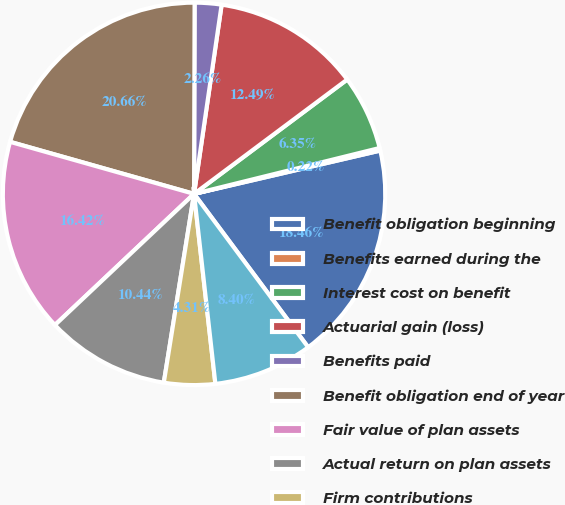<chart> <loc_0><loc_0><loc_500><loc_500><pie_chart><fcel>Benefit obligation beginning<fcel>Benefits earned during the<fcel>Interest cost on benefit<fcel>Actuarial gain (loss)<fcel>Benefits paid<fcel>Benefit obligation end of year<fcel>Fair value of plan assets<fcel>Actual return on plan assets<fcel>Firm contributions<fcel>Funded (unfunded) status<nl><fcel>18.46%<fcel>0.22%<fcel>6.35%<fcel>12.49%<fcel>2.26%<fcel>20.66%<fcel>16.42%<fcel>10.44%<fcel>4.31%<fcel>8.4%<nl></chart> 